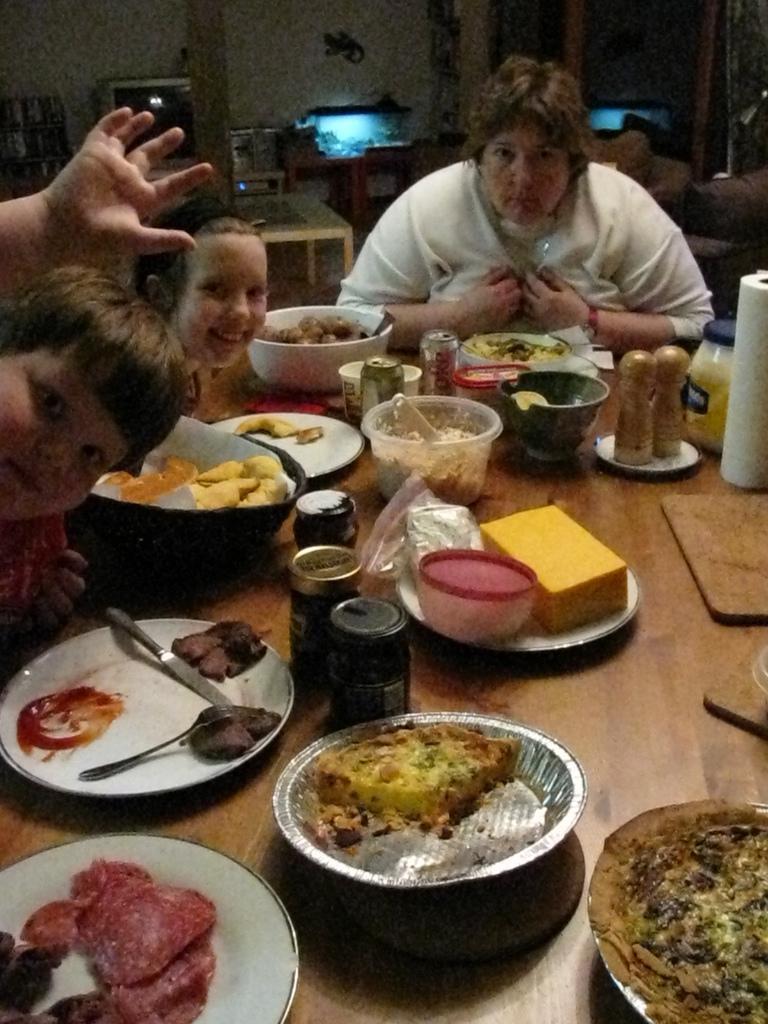Can you describe this image briefly? This picture shows plates, Bottles And bowls with food and we see couple of cans on the table and we see a woman and a couple of kids seated on the chairs and we see another table on the back and a poster on the wall. 